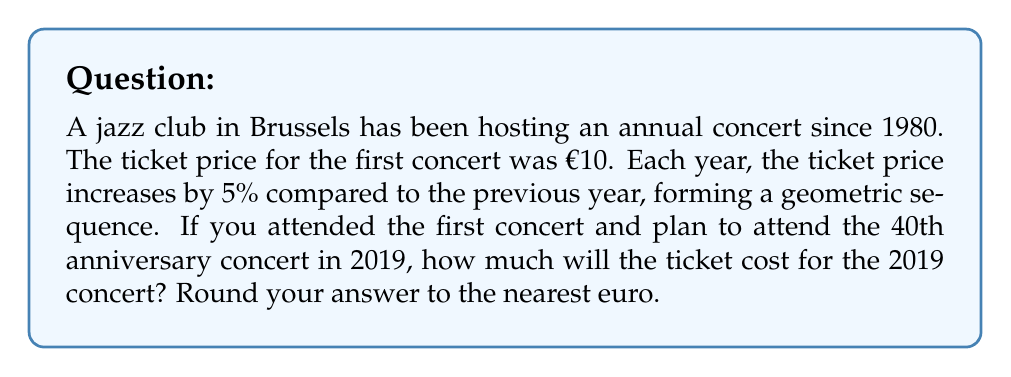Can you solve this math problem? Let's approach this step-by-step:

1) We have a geometric sequence where:
   - Initial term, $a_1 = 10$
   - Common ratio, $r = 1.05$ (5% increase = 1 + 0.05 = 1.05)
   - We need to find the 40th term, $a_{40}$

2) The formula for the nth term of a geometric sequence is:
   $a_n = a_1 \cdot r^{n-1}$

3) Substituting our values:
   $a_{40} = 10 \cdot (1.05)^{40-1}$
   $a_{40} = 10 \cdot (1.05)^{39}$

4) Now, let's calculate:
   $a_{40} = 10 \cdot 6.7054$
   $a_{40} = 67.054$

5) Rounding to the nearest euro:
   $a_{40} \approx 67$

Therefore, the ticket for the 40th anniversary concert in 2019 will cost approximately €67.
Answer: €67 